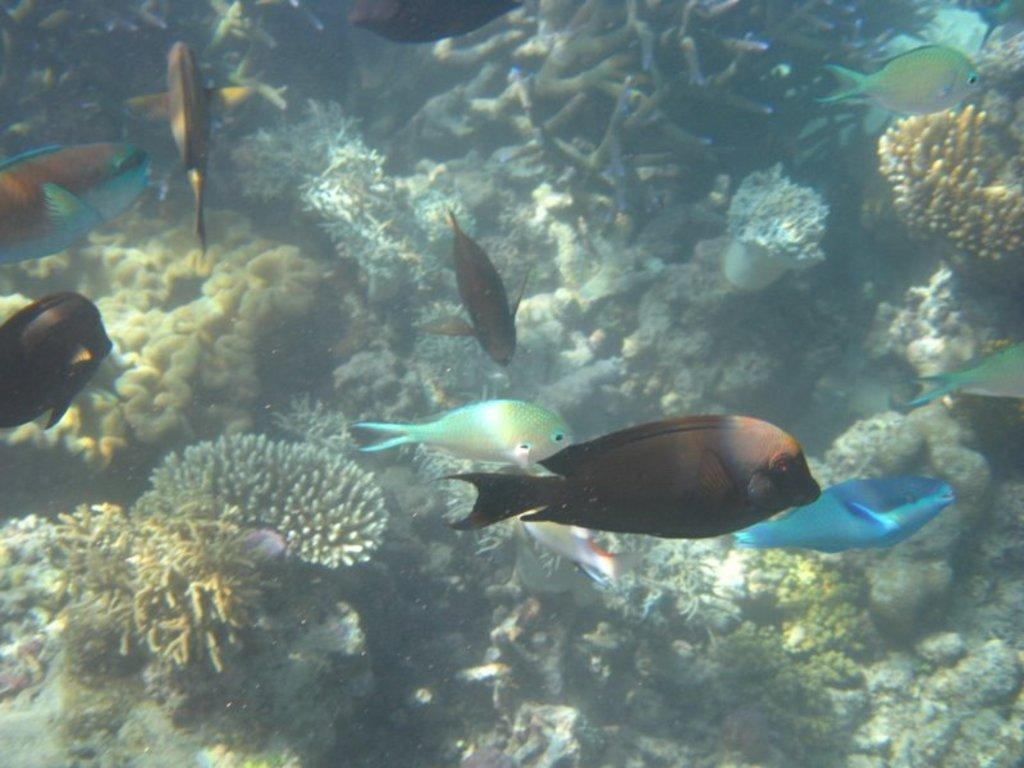What type of animals can be seen in the image? There are fishes in the image. What other objects or features can be seen in the image? There are corals in the image. What is the primary environment in which the fishes and corals are located? The fishes and corals are in water. What type of doll does the daughter play with in the image? There is no daughter or doll present in the image; it features fishes and corals in water. 